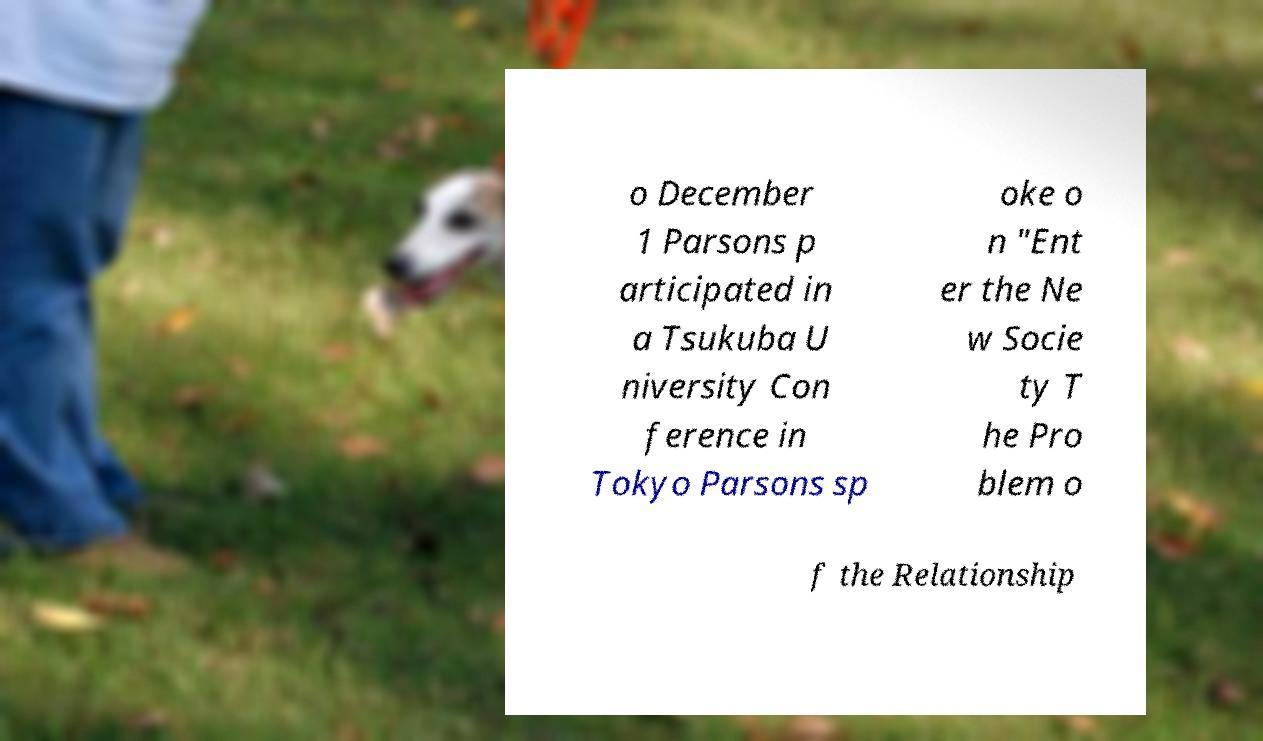For documentation purposes, I need the text within this image transcribed. Could you provide that? o December 1 Parsons p articipated in a Tsukuba U niversity Con ference in Tokyo Parsons sp oke o n "Ent er the Ne w Socie ty T he Pro blem o f the Relationship 